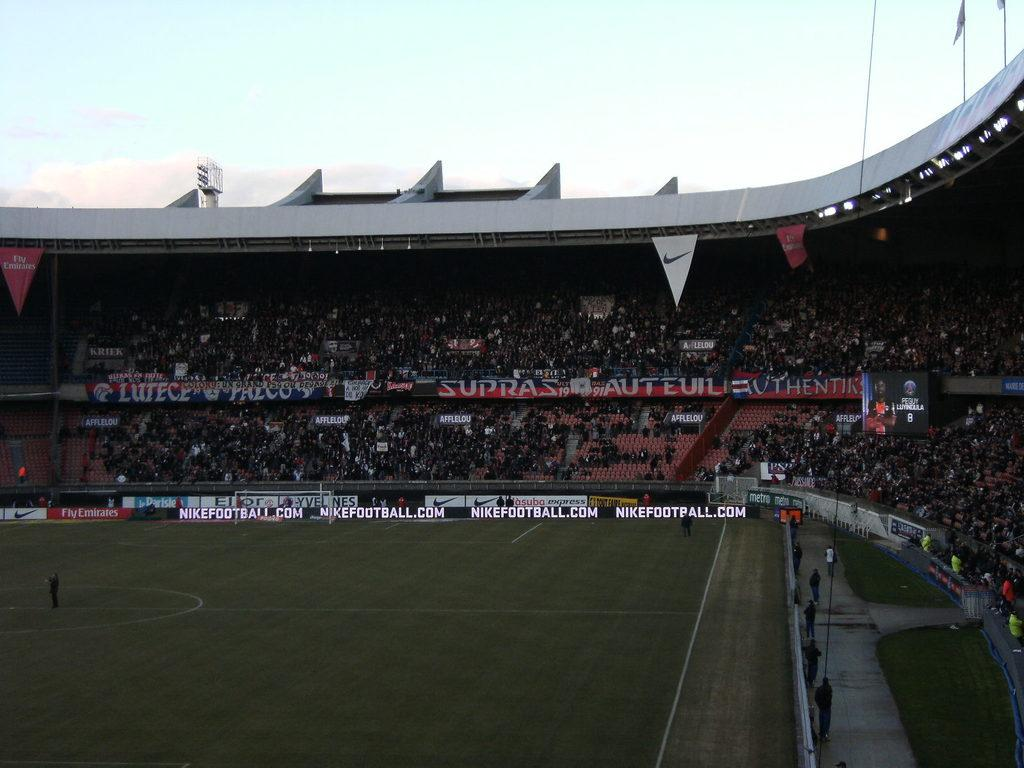<image>
Summarize the visual content of the image. A football field with advertisements for Nike around the seats 